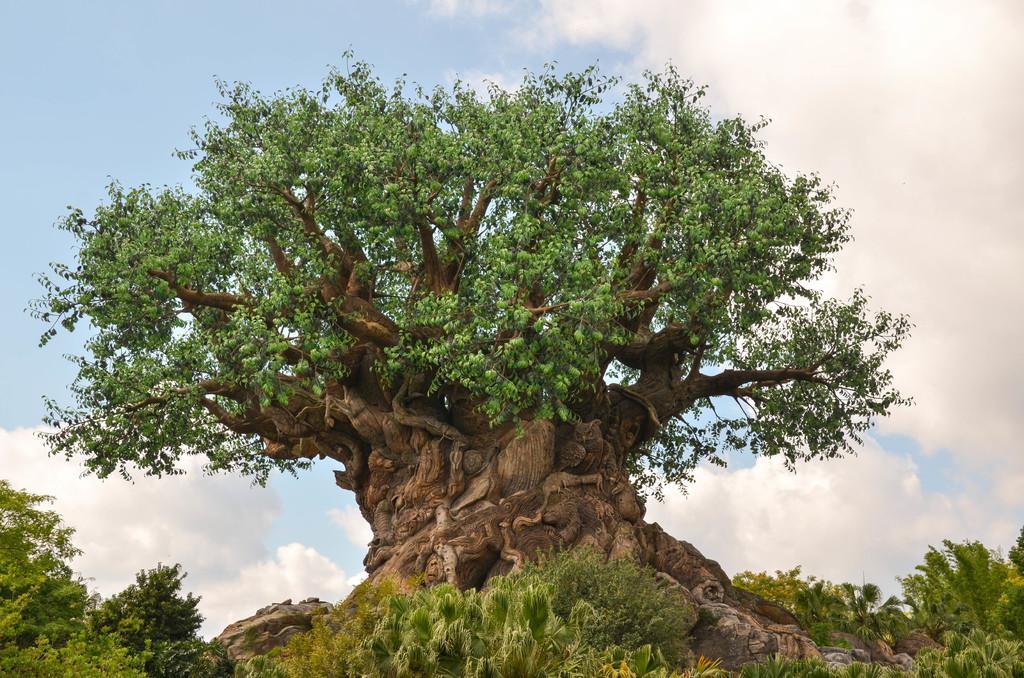Please provide a concise description of this image. In this picture we can see plants and trees. In the background of the image we can see the sky with clouds. 